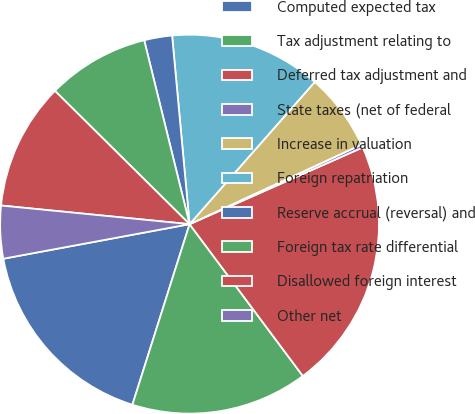<chart> <loc_0><loc_0><loc_500><loc_500><pie_chart><fcel>Computed expected tax<fcel>Tax adjustment relating to<fcel>Deferred tax adjustment and<fcel>State taxes (net of federal<fcel>Increase in valuation<fcel>Foreign repatriation<fcel>Reserve accrual (reversal) and<fcel>Foreign tax rate differential<fcel>Disallowed foreign interest<fcel>Other net<nl><fcel>17.2%<fcel>15.08%<fcel>21.44%<fcel>0.26%<fcel>6.61%<fcel>12.96%<fcel>2.38%<fcel>8.73%<fcel>10.85%<fcel>4.49%<nl></chart> 